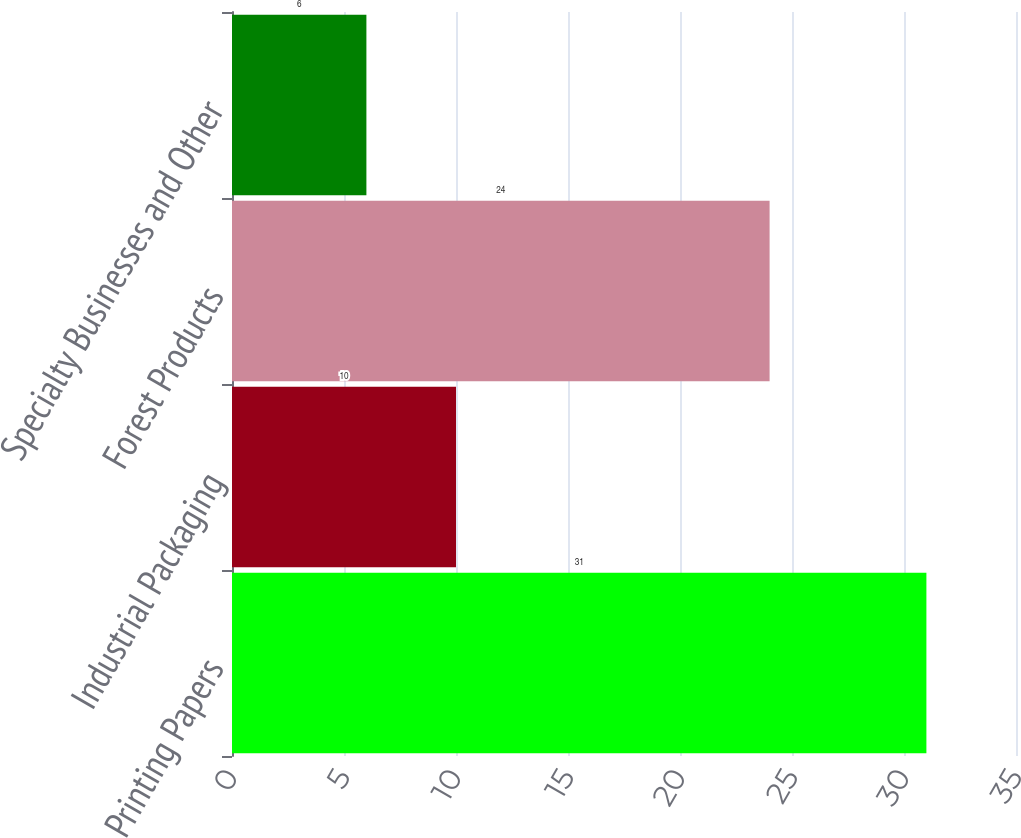Convert chart. <chart><loc_0><loc_0><loc_500><loc_500><bar_chart><fcel>Printing Papers<fcel>Industrial Packaging<fcel>Forest Products<fcel>Specialty Businesses and Other<nl><fcel>31<fcel>10<fcel>24<fcel>6<nl></chart> 